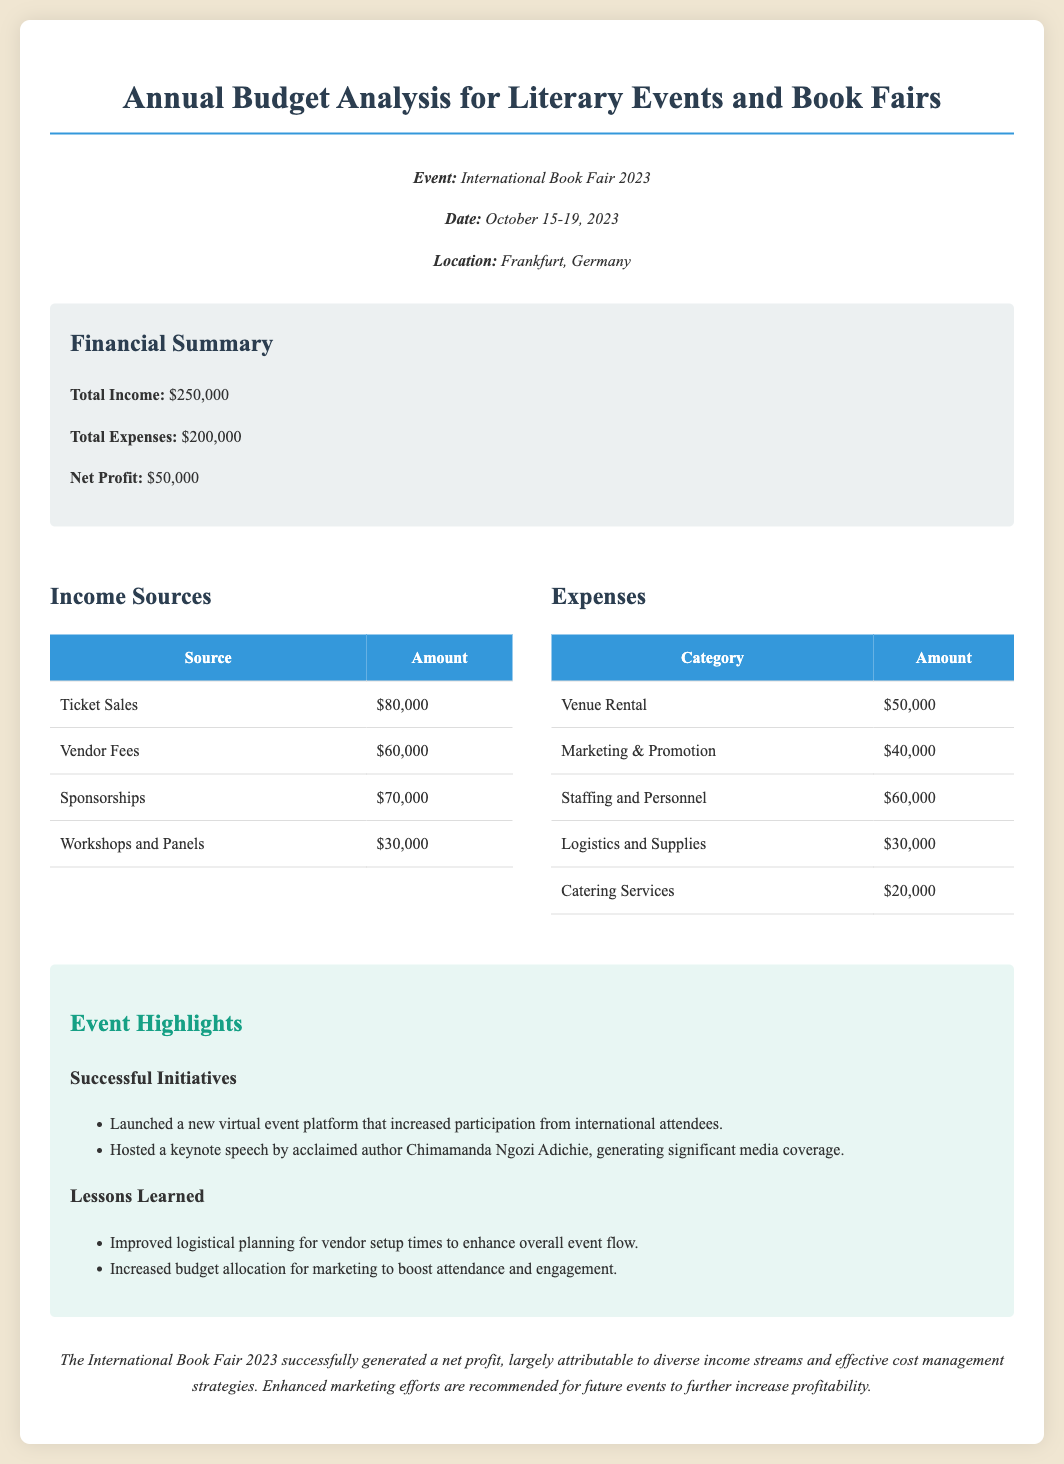what is the total income? The total income is explicitly stated in the summary section of the document.
Answer: $250,000 what are the total expenses? The total expenses are listed in the financial summary section.
Answer: $200,000 what is the net profit? The net profit can be derived by subtracting total expenses from total income, as mentioned in the summary.
Answer: $50,000 how much was generated from ticket sales? The amount generated from ticket sales is provided in the income sources table.
Answer: $80,000 which author gave a keynote speech at the event? The name of the author who gave a keynote speech is mentioned in the highlights section.
Answer: Chimamanda Ngozi Adichie what was the cost of marketing and promotion? The cost of marketing and promotion is found in the expenses table under the relevant category.
Answer: $40,000 how much income was generated from sponsorships? The amount generated from sponsorships is listed in the income sources table.
Answer: $70,000 what was the highest expense category? The expenses can be compared from the expenses table to determine which category had the highest cost.
Answer: Staffing and Personnel what recommendation is made for future events? The recommendation for future events is stated in the conclusion section.
Answer: Increased budget allocation for marketing 